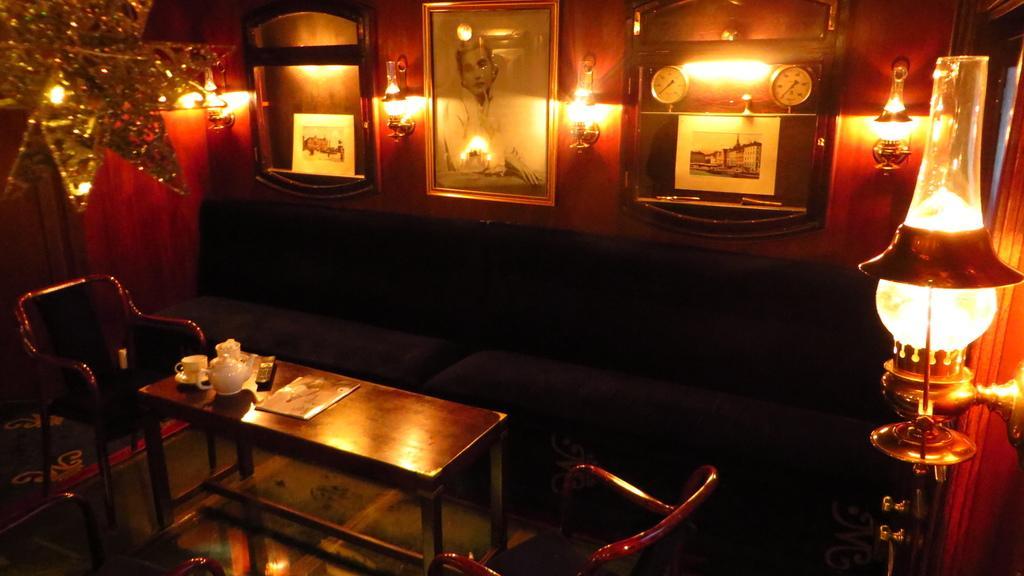Could you give a brief overview of what you see in this image? In this image we can see sofas and there is a table. We can see a teapot, cups, saucer and books placed on the table. There are chairs. On the left there is a decor. On the right there is a lamp. In the background there is a wall and we can see frames placed on the wall. 